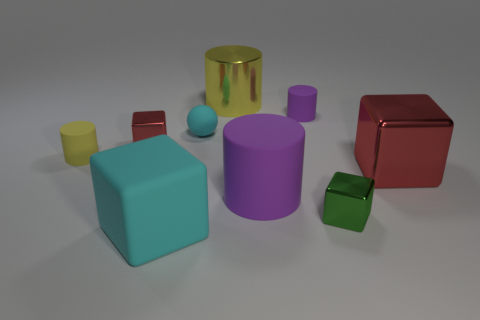Add 1 big yellow metal blocks. How many objects exist? 10 Subtract all spheres. How many objects are left? 8 Subtract 0 green balls. How many objects are left? 9 Subtract all large purple matte objects. Subtract all big blocks. How many objects are left? 6 Add 1 yellow cylinders. How many yellow cylinders are left? 3 Add 6 big cylinders. How many big cylinders exist? 8 